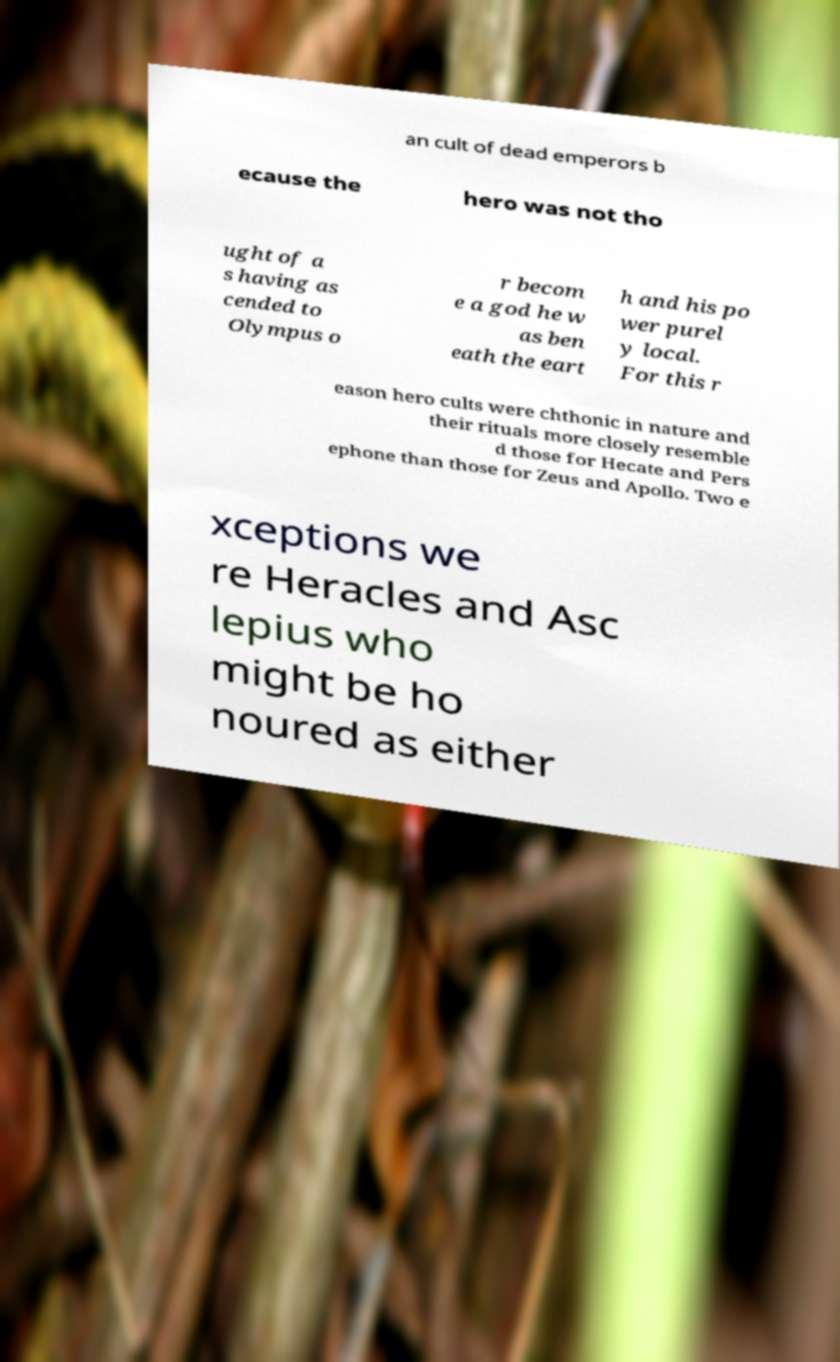Can you accurately transcribe the text from the provided image for me? an cult of dead emperors b ecause the hero was not tho ught of a s having as cended to Olympus o r becom e a god he w as ben eath the eart h and his po wer purel y local. For this r eason hero cults were chthonic in nature and their rituals more closely resemble d those for Hecate and Pers ephone than those for Zeus and Apollo. Two e xceptions we re Heracles and Asc lepius who might be ho noured as either 